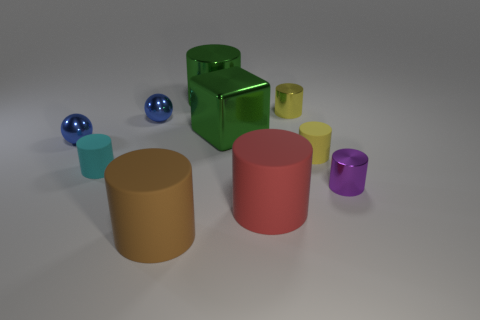Can you tell me the colors of the objects and how many of each are there? Certainly! In the image, there are blue, green, yellow, red, and purple objects. Specifically, there are two blue balls, one green cube and one green cylinder, one yellow cylinder, two red cylinders of different sizes, and one small purple cylinder.  Which objects are reflective, and how does that affect their appearance? The two blue balls and the green cube are reflective. This gives them a shiny appearance, with enhanced highlights and visible reflections on their surfaces, contrasting with the matte finish of the other objects. 